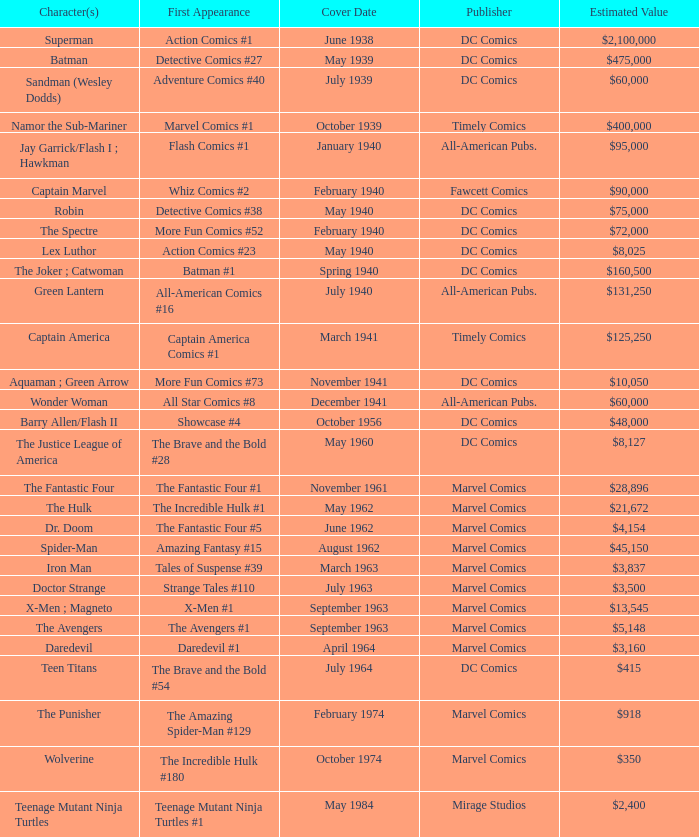Who issues wolverine? Marvel Comics. 